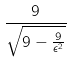Convert formula to latex. <formula><loc_0><loc_0><loc_500><loc_500>\frac { 9 } { \sqrt { 9 - \frac { 9 } { \epsilon ^ { 2 } } } }</formula> 